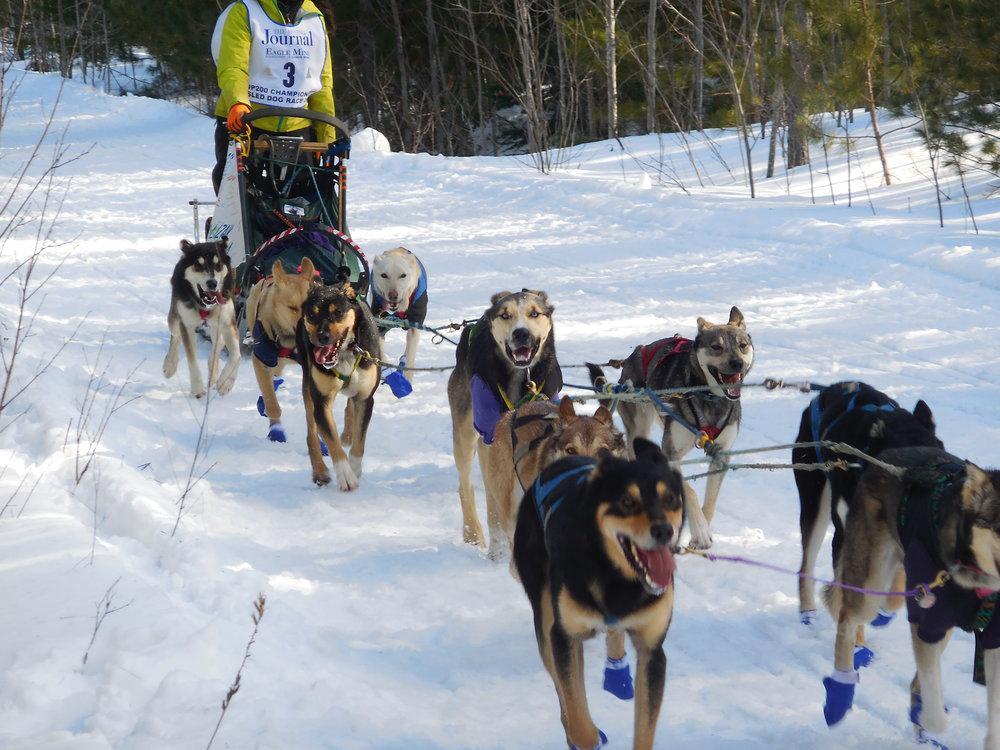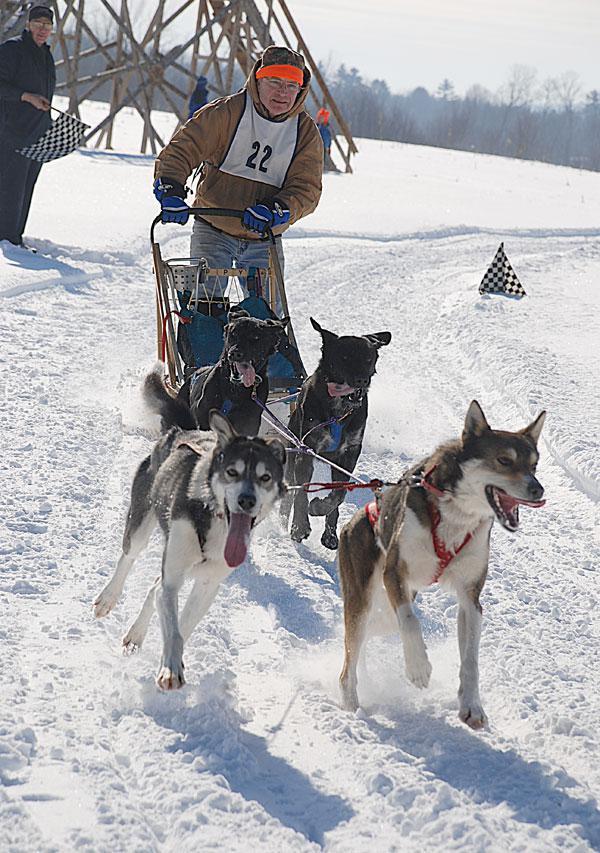The first image is the image on the left, the second image is the image on the right. Given the left and right images, does the statement "Some dogs are wearing booties." hold true? Answer yes or no. Yes. The first image is the image on the left, the second image is the image on the right. Analyze the images presented: Is the assertion "sled dogs are wearing protective foot coverings" valid? Answer yes or no. Yes. 